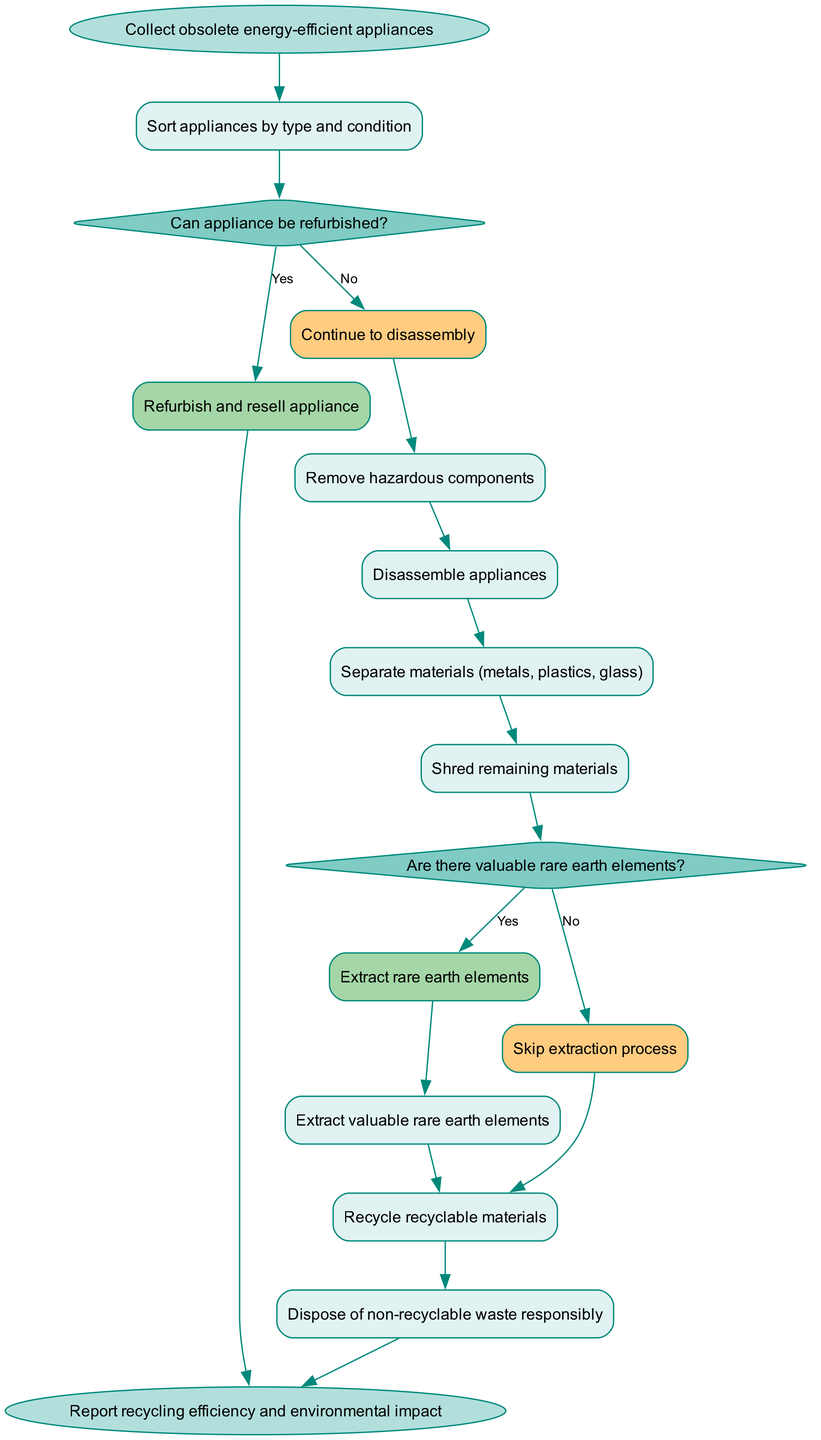What is the starting point of the recycling workflow? The starting point of the diagram is clearly labeled as "Collect obsolete energy-efficient appliances". This is the first node that initiates the entire process depicted in the activity diagram.
Answer: Collect obsolete energy-efficient appliances How many activities are included in the diagram? By counting the number of activities listed in the "activities" section, we find there are eight distinct activities described in the workflow.
Answer: 8 What happens if an appliance can be refurbished? According to the diagram, if an appliance can be refurbished, the subsequent action taken is to "Refurbish and resell appliance". This is indicated as a direct pathway from the decision node.
Answer: Refurbish and resell appliance What are the types of materials separated during disassembly? The separation of materials identified in the workflow involves three categories: metals, plastics, and glass. This is mentioned specifically in the related activity.
Answer: Metals, plastics, glass After shredding materials, what is the next decision? Following the shredding of materials, the workflow includes a decision asking "Are there valuable rare earth elements?" This decision determines the next action step based on the presence of rare earth elements.
Answer: Are there valuable rare earth elements? What is the final outcome reported in the workflow? The final node in the diagram indicates that the outcome is to "Report recycling efficiency and environmental impact". This summarizes the results of the entire recycling process.
Answer: Report recycling efficiency and environmental impact What type of waste is disposed of at the end of the process? The diagram dictates that any waste that is non-recyclable will be "Disposed of non-recyclable waste responsibly". This indicates the responsible handling of waste that cannot be recycled.
Answer: Dispose of non-recyclable waste responsibly What follows after the extraction of rare earth elements? After extracting valuable rare earth elements, the next step in the workflow is to "Recycle recyclable materials". This shows the continuous flow of actions after the extraction process.
Answer: Recycle recyclable materials 